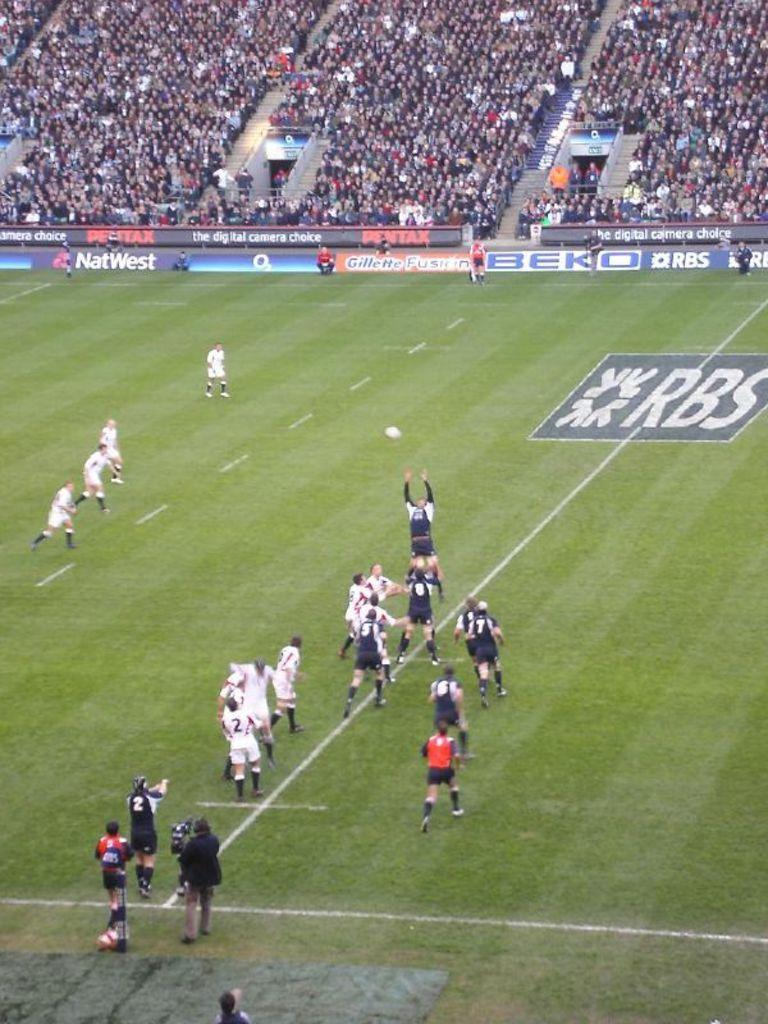<image>
Describe the image concisely. Two soccer teams are running after the ball with the logo for RBS on the center of the field. 